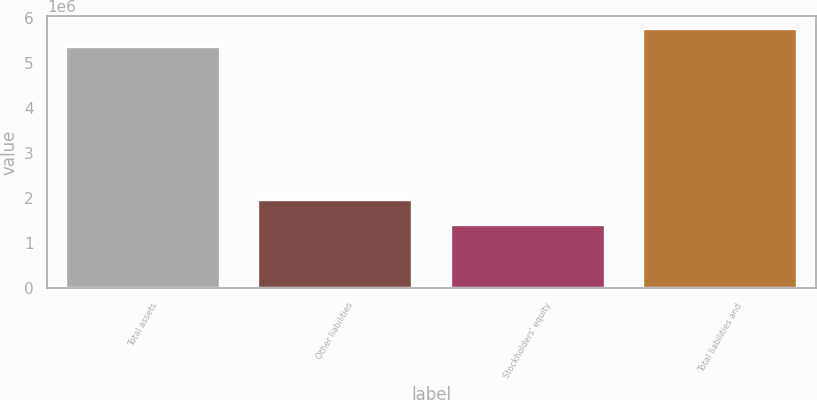Convert chart to OTSL. <chart><loc_0><loc_0><loc_500><loc_500><bar_chart><fcel>Total assets<fcel>Other liabilities<fcel>Stockholders' equity<fcel>Total liabilities and<nl><fcel>5.35972e+06<fcel>1.96685e+06<fcel>1.40586e+06<fcel>5.75511e+06<nl></chart> 